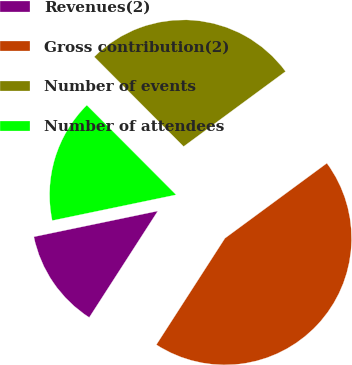<chart> <loc_0><loc_0><loc_500><loc_500><pie_chart><fcel>Revenues(2)<fcel>Gross contribution(2)<fcel>Number of events<fcel>Number of attendees<nl><fcel>12.63%<fcel>44.21%<fcel>27.37%<fcel>15.79%<nl></chart> 